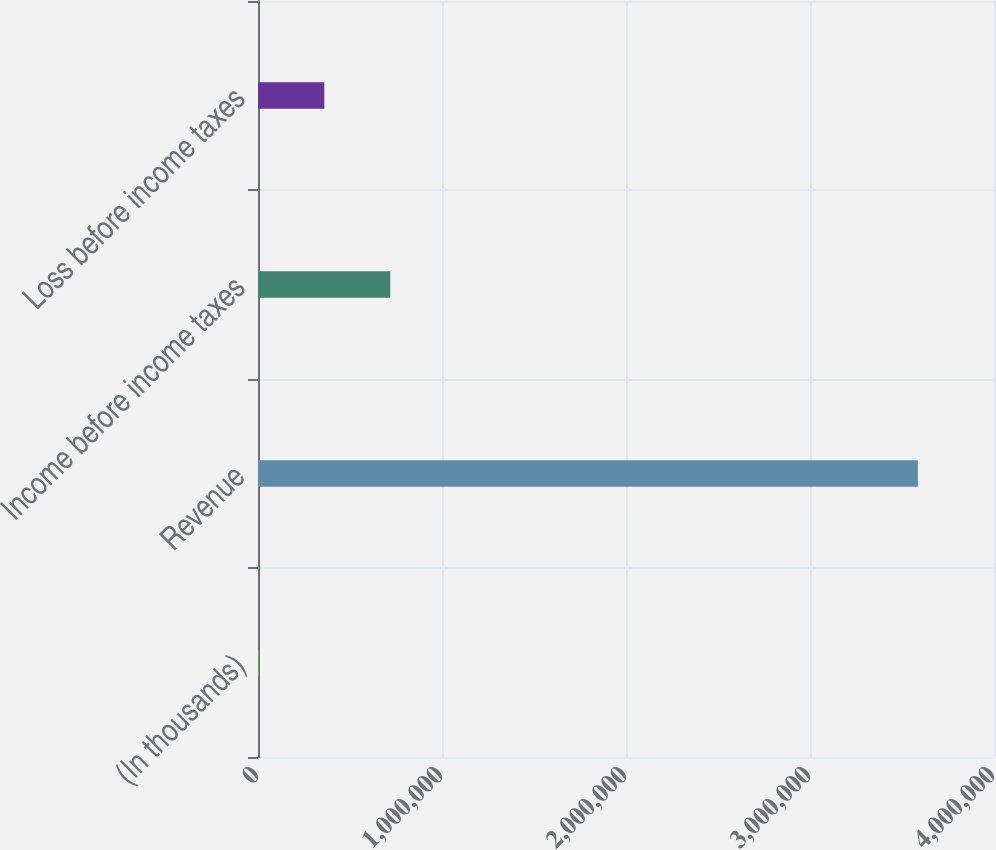Convert chart to OTSL. <chart><loc_0><loc_0><loc_500><loc_500><bar_chart><fcel>(In thousands)<fcel>Revenue<fcel>Income before income taxes<fcel>Loss before income taxes<nl><fcel>2011<fcel>3.58618e+06<fcel>718845<fcel>360428<nl></chart> 